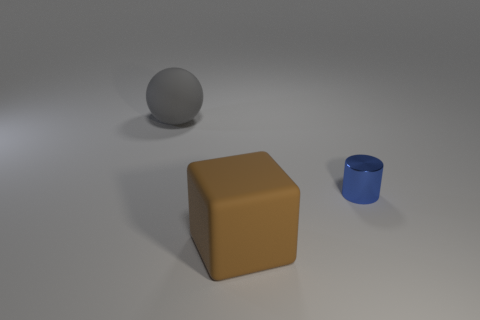Add 2 small cyan metal things. How many objects exist? 5 Subtract all blocks. How many objects are left? 2 Subtract 0 cyan spheres. How many objects are left? 3 Subtract all big balls. Subtract all brown rubber things. How many objects are left? 1 Add 1 big gray spheres. How many big gray spheres are left? 2 Add 3 small purple metallic blocks. How many small purple metallic blocks exist? 3 